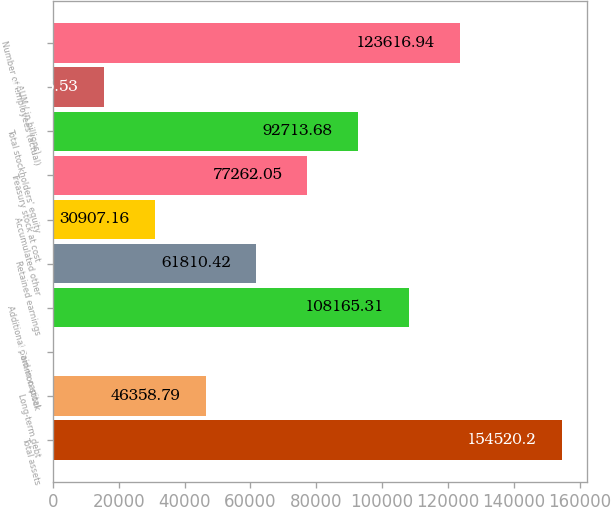Convert chart. <chart><loc_0><loc_0><loc_500><loc_500><bar_chart><fcel>Total assets<fcel>Long-term debt<fcel>Common stock<fcel>Additional paid-in capital<fcel>Retained earnings<fcel>Accumulated other<fcel>Treasury stock at cost<fcel>Total stockholders' equity<fcel>AUM ( in billions)<fcel>Number of employees (actual)<nl><fcel>154520<fcel>46358.8<fcel>3.9<fcel>108165<fcel>61810.4<fcel>30907.2<fcel>77262.1<fcel>92713.7<fcel>15455.5<fcel>123617<nl></chart> 